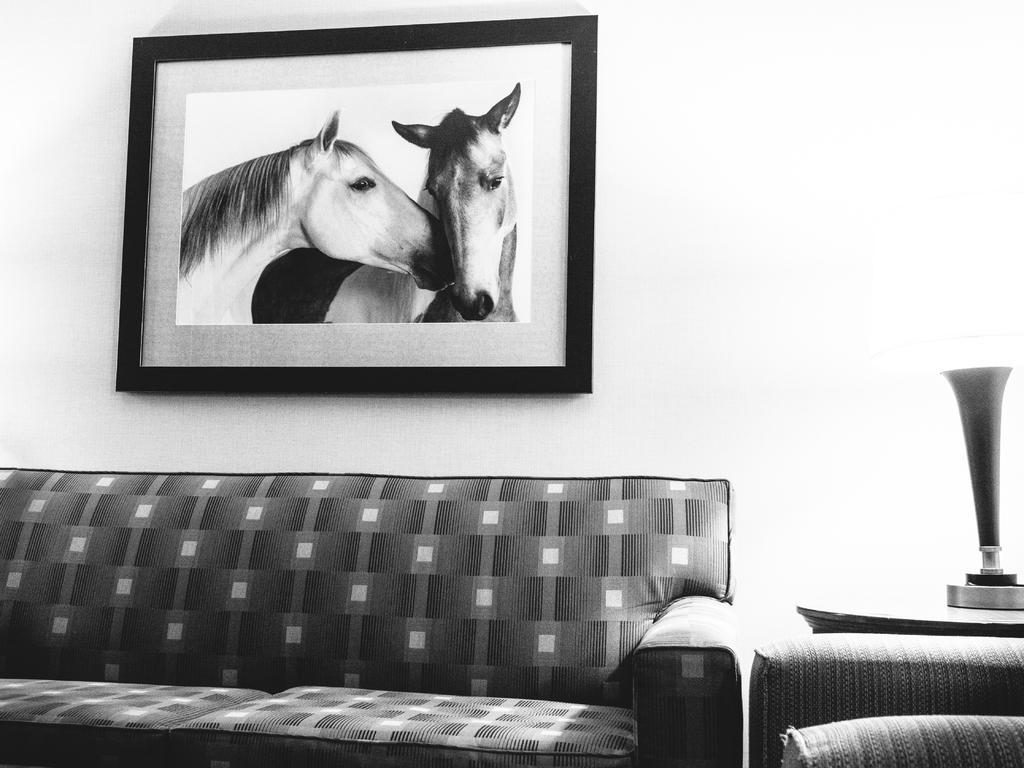Could you give a brief overview of what you see in this image? This is a black and white image where it consists of a sofa and there is a lamp on the right side. There is a photo frame to that wall. In that photo frame there is a picture of two horses. 